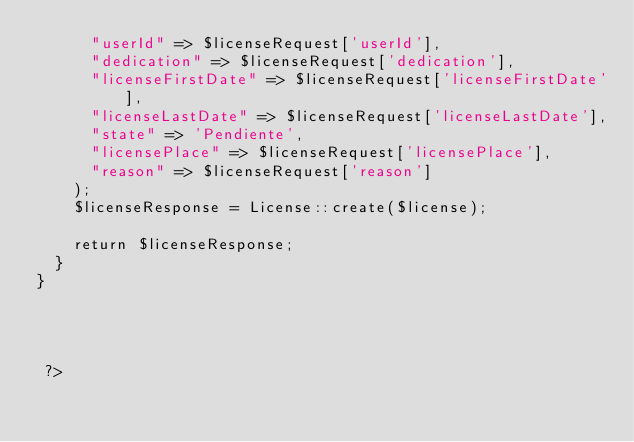<code> <loc_0><loc_0><loc_500><loc_500><_PHP_>      "userId" => $licenseRequest['userId'],
      "dedication" => $licenseRequest['dedication'],
      "licenseFirstDate" => $licenseRequest['licenseFirstDate'],
      "licenseLastDate" => $licenseRequest['licenseLastDate'],
      "state" => 'Pendiente',
      "licensePlace" => $licenseRequest['licensePlace'],
      "reason" => $licenseRequest['reason']
    );
    $licenseResponse = License::create($license);

    return $licenseResponse;
  }
}




 ?>
</code> 